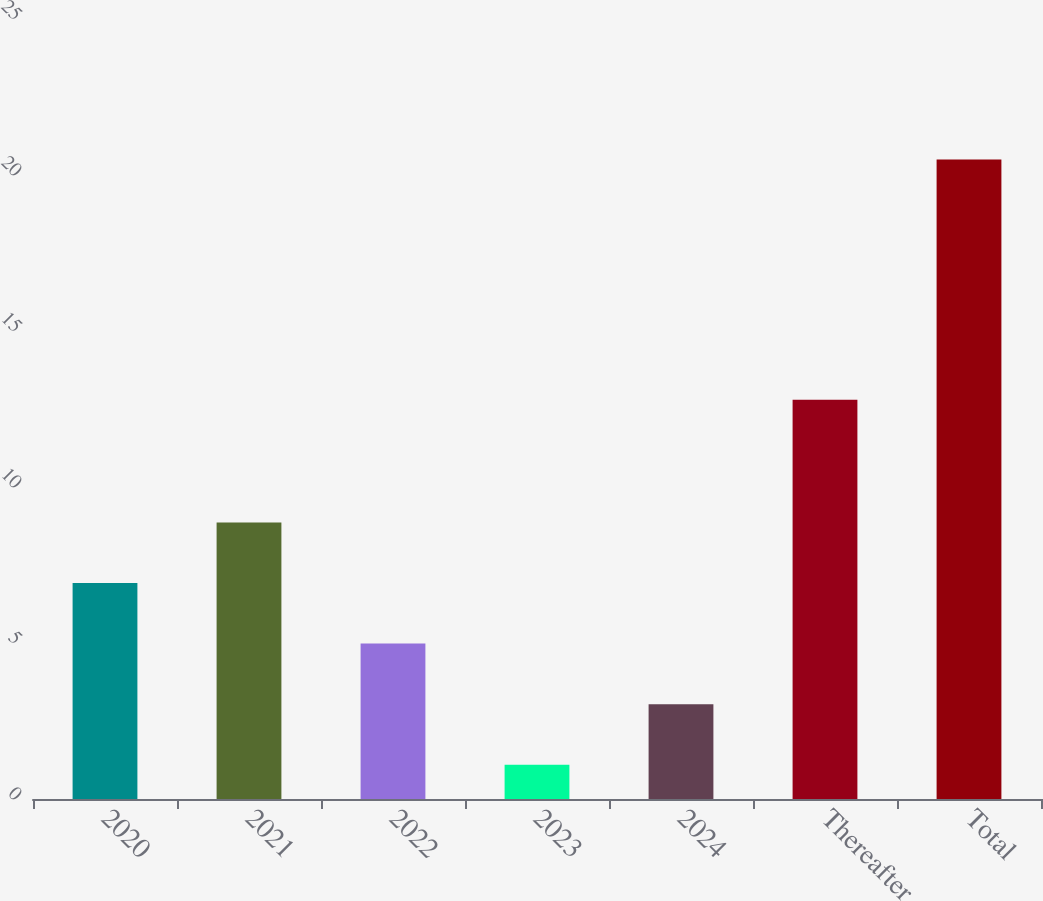Convert chart to OTSL. <chart><loc_0><loc_0><loc_500><loc_500><bar_chart><fcel>2020<fcel>2021<fcel>2022<fcel>2023<fcel>2024<fcel>Thereafter<fcel>Total<nl><fcel>6.92<fcel>8.86<fcel>4.98<fcel>1.1<fcel>3.04<fcel>12.8<fcel>20.5<nl></chart> 